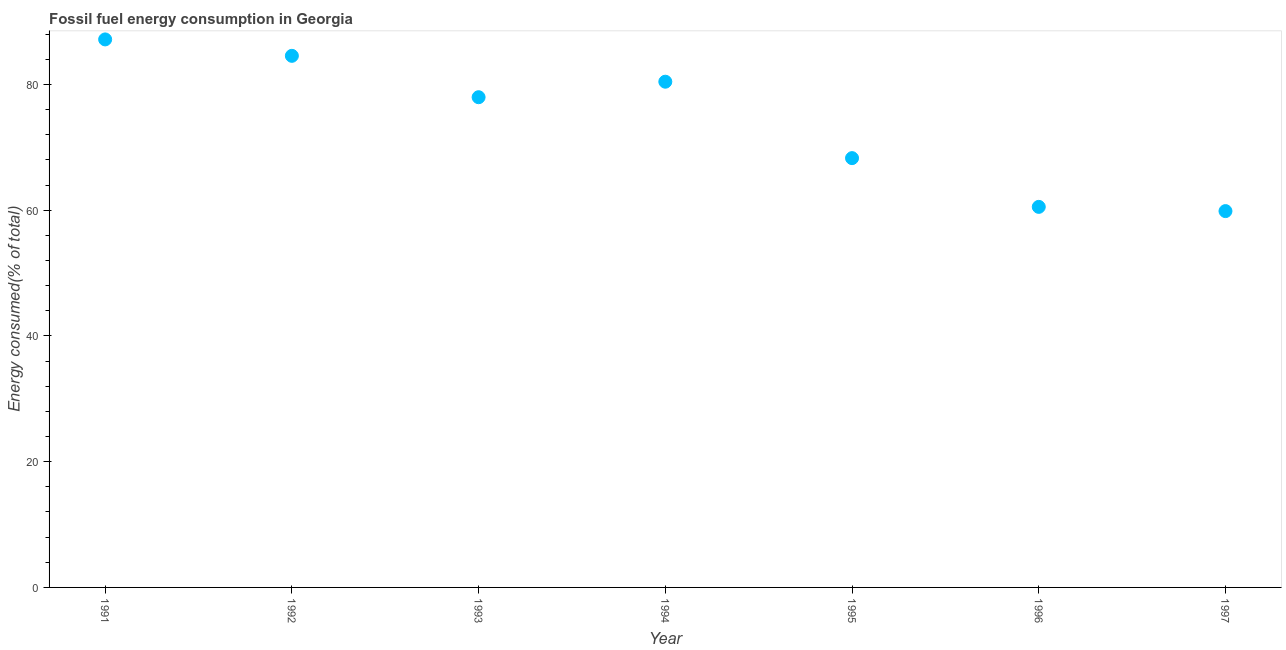What is the fossil fuel energy consumption in 1994?
Provide a short and direct response. 80.45. Across all years, what is the maximum fossil fuel energy consumption?
Keep it short and to the point. 87.18. Across all years, what is the minimum fossil fuel energy consumption?
Keep it short and to the point. 59.87. What is the sum of the fossil fuel energy consumption?
Make the answer very short. 518.88. What is the difference between the fossil fuel energy consumption in 1992 and 1996?
Offer a terse response. 24.03. What is the average fossil fuel energy consumption per year?
Your answer should be very brief. 74.13. What is the median fossil fuel energy consumption?
Your response must be concise. 77.98. In how many years, is the fossil fuel energy consumption greater than 8 %?
Provide a short and direct response. 7. Do a majority of the years between 1991 and 1992 (inclusive) have fossil fuel energy consumption greater than 64 %?
Make the answer very short. Yes. What is the ratio of the fossil fuel energy consumption in 1991 to that in 1996?
Provide a short and direct response. 1.44. What is the difference between the highest and the second highest fossil fuel energy consumption?
Your answer should be compact. 2.61. Is the sum of the fossil fuel energy consumption in 1992 and 1996 greater than the maximum fossil fuel energy consumption across all years?
Keep it short and to the point. Yes. What is the difference between the highest and the lowest fossil fuel energy consumption?
Your answer should be very brief. 27.31. In how many years, is the fossil fuel energy consumption greater than the average fossil fuel energy consumption taken over all years?
Provide a succinct answer. 4. Does the fossil fuel energy consumption monotonically increase over the years?
Make the answer very short. No. How many dotlines are there?
Your response must be concise. 1. What is the difference between two consecutive major ticks on the Y-axis?
Offer a very short reply. 20. Are the values on the major ticks of Y-axis written in scientific E-notation?
Your answer should be very brief. No. Does the graph contain any zero values?
Your response must be concise. No. Does the graph contain grids?
Keep it short and to the point. No. What is the title of the graph?
Keep it short and to the point. Fossil fuel energy consumption in Georgia. What is the label or title of the X-axis?
Offer a terse response. Year. What is the label or title of the Y-axis?
Offer a very short reply. Energy consumed(% of total). What is the Energy consumed(% of total) in 1991?
Provide a short and direct response. 87.18. What is the Energy consumed(% of total) in 1992?
Your response must be concise. 84.57. What is the Energy consumed(% of total) in 1993?
Your answer should be compact. 77.98. What is the Energy consumed(% of total) in 1994?
Give a very brief answer. 80.45. What is the Energy consumed(% of total) in 1995?
Provide a short and direct response. 68.29. What is the Energy consumed(% of total) in 1996?
Make the answer very short. 60.54. What is the Energy consumed(% of total) in 1997?
Your answer should be very brief. 59.87. What is the difference between the Energy consumed(% of total) in 1991 and 1992?
Offer a very short reply. 2.61. What is the difference between the Energy consumed(% of total) in 1991 and 1993?
Make the answer very short. 9.2. What is the difference between the Energy consumed(% of total) in 1991 and 1994?
Keep it short and to the point. 6.73. What is the difference between the Energy consumed(% of total) in 1991 and 1995?
Your answer should be very brief. 18.89. What is the difference between the Energy consumed(% of total) in 1991 and 1996?
Offer a very short reply. 26.64. What is the difference between the Energy consumed(% of total) in 1991 and 1997?
Ensure brevity in your answer.  27.31. What is the difference between the Energy consumed(% of total) in 1992 and 1993?
Keep it short and to the point. 6.58. What is the difference between the Energy consumed(% of total) in 1992 and 1994?
Keep it short and to the point. 4.12. What is the difference between the Energy consumed(% of total) in 1992 and 1995?
Your response must be concise. 16.27. What is the difference between the Energy consumed(% of total) in 1992 and 1996?
Offer a very short reply. 24.03. What is the difference between the Energy consumed(% of total) in 1992 and 1997?
Ensure brevity in your answer.  24.7. What is the difference between the Energy consumed(% of total) in 1993 and 1994?
Offer a terse response. -2.47. What is the difference between the Energy consumed(% of total) in 1993 and 1995?
Your response must be concise. 9.69. What is the difference between the Energy consumed(% of total) in 1993 and 1996?
Your response must be concise. 17.44. What is the difference between the Energy consumed(% of total) in 1993 and 1997?
Your answer should be very brief. 18.12. What is the difference between the Energy consumed(% of total) in 1994 and 1995?
Your answer should be very brief. 12.16. What is the difference between the Energy consumed(% of total) in 1994 and 1996?
Keep it short and to the point. 19.91. What is the difference between the Energy consumed(% of total) in 1994 and 1997?
Provide a succinct answer. 20.59. What is the difference between the Energy consumed(% of total) in 1995 and 1996?
Give a very brief answer. 7.75. What is the difference between the Energy consumed(% of total) in 1995 and 1997?
Your response must be concise. 8.43. What is the difference between the Energy consumed(% of total) in 1996 and 1997?
Offer a terse response. 0.67. What is the ratio of the Energy consumed(% of total) in 1991 to that in 1992?
Your answer should be very brief. 1.03. What is the ratio of the Energy consumed(% of total) in 1991 to that in 1993?
Your answer should be compact. 1.12. What is the ratio of the Energy consumed(% of total) in 1991 to that in 1994?
Give a very brief answer. 1.08. What is the ratio of the Energy consumed(% of total) in 1991 to that in 1995?
Your response must be concise. 1.28. What is the ratio of the Energy consumed(% of total) in 1991 to that in 1996?
Your answer should be very brief. 1.44. What is the ratio of the Energy consumed(% of total) in 1991 to that in 1997?
Offer a very short reply. 1.46. What is the ratio of the Energy consumed(% of total) in 1992 to that in 1993?
Ensure brevity in your answer.  1.08. What is the ratio of the Energy consumed(% of total) in 1992 to that in 1994?
Your response must be concise. 1.05. What is the ratio of the Energy consumed(% of total) in 1992 to that in 1995?
Your answer should be compact. 1.24. What is the ratio of the Energy consumed(% of total) in 1992 to that in 1996?
Your answer should be very brief. 1.4. What is the ratio of the Energy consumed(% of total) in 1992 to that in 1997?
Ensure brevity in your answer.  1.41. What is the ratio of the Energy consumed(% of total) in 1993 to that in 1995?
Your answer should be very brief. 1.14. What is the ratio of the Energy consumed(% of total) in 1993 to that in 1996?
Your response must be concise. 1.29. What is the ratio of the Energy consumed(% of total) in 1993 to that in 1997?
Offer a terse response. 1.3. What is the ratio of the Energy consumed(% of total) in 1994 to that in 1995?
Offer a terse response. 1.18. What is the ratio of the Energy consumed(% of total) in 1994 to that in 1996?
Make the answer very short. 1.33. What is the ratio of the Energy consumed(% of total) in 1994 to that in 1997?
Ensure brevity in your answer.  1.34. What is the ratio of the Energy consumed(% of total) in 1995 to that in 1996?
Give a very brief answer. 1.13. What is the ratio of the Energy consumed(% of total) in 1995 to that in 1997?
Make the answer very short. 1.14. What is the ratio of the Energy consumed(% of total) in 1996 to that in 1997?
Offer a very short reply. 1.01. 